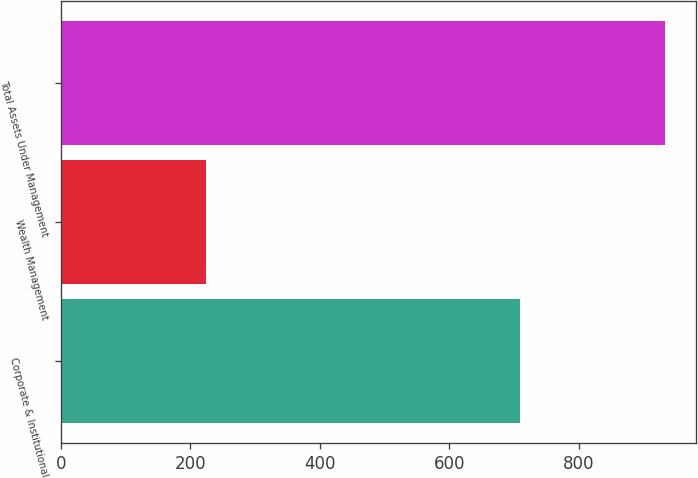Convert chart to OTSL. <chart><loc_0><loc_0><loc_500><loc_500><bar_chart><fcel>Corporate & Institutional<fcel>Wealth Management<fcel>Total Assets Under Management<nl><fcel>709.6<fcel>224.5<fcel>934.1<nl></chart> 